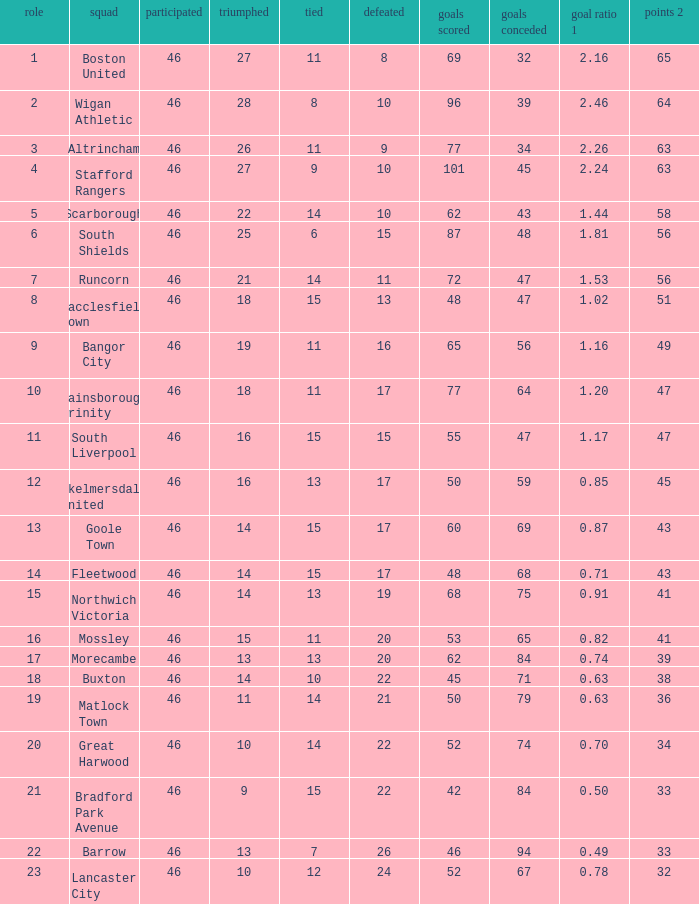How many points did Goole Town accumulate? 1.0. 